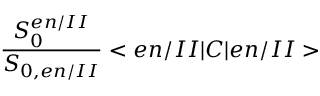<formula> <loc_0><loc_0><loc_500><loc_500>\frac { S _ { 0 } ^ { e n / I I } } { S _ { 0 , e n / I I } } < e n / I I | C | e n / I I ></formula> 